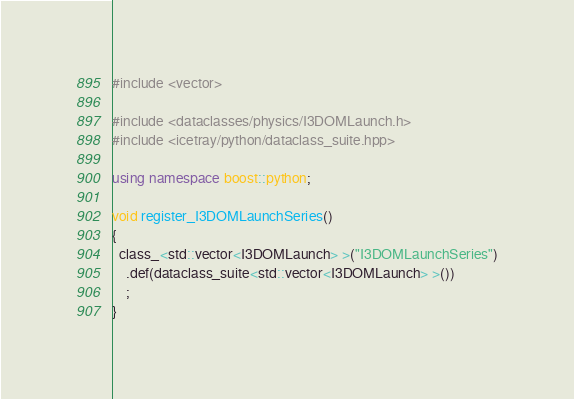Convert code to text. <code><loc_0><loc_0><loc_500><loc_500><_C++_>#include <vector>

#include <dataclasses/physics/I3DOMLaunch.h>
#include <icetray/python/dataclass_suite.hpp>

using namespace boost::python;

void register_I3DOMLaunchSeries()
{
  class_<std::vector<I3DOMLaunch> >("I3DOMLaunchSeries")
    .def(dataclass_suite<std::vector<I3DOMLaunch> >())
    ;
}
</code> 